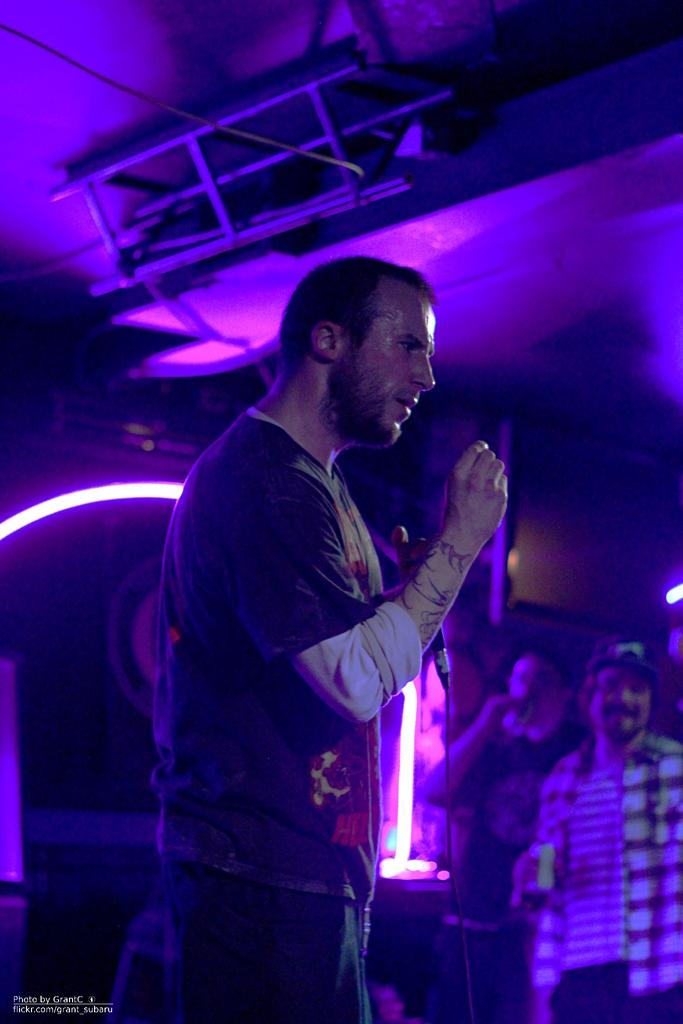What are the people in the image doing? The people are standing on a stage. What can be seen in the background of the image? There is a light in the background. Where is the text located in the image? The text is in the bottom left of the image. What type of cherries are being sorted by the people on the stage? There are no cherries or sorting activity present in the image. 